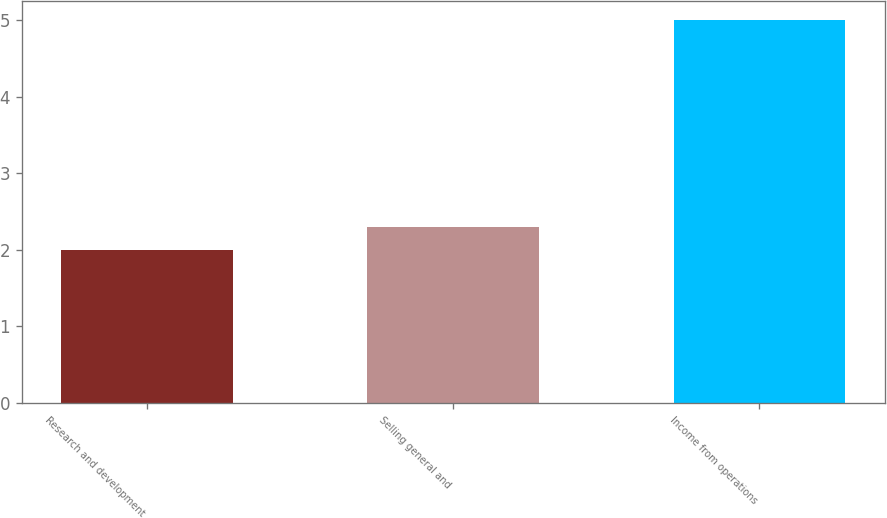Convert chart to OTSL. <chart><loc_0><loc_0><loc_500><loc_500><bar_chart><fcel>Research and development<fcel>Selling general and<fcel>Income from operations<nl><fcel>2<fcel>2.3<fcel>5<nl></chart> 